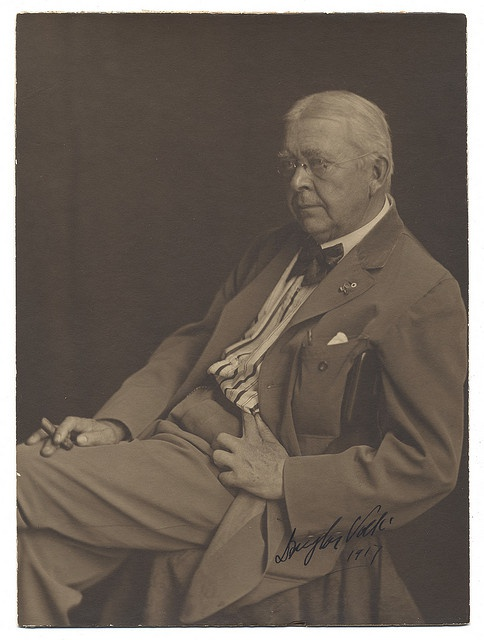Describe the objects in this image and their specific colors. I can see people in white, gray, and black tones, chair in white, black, and gray tones, and tie in white, black, and gray tones in this image. 